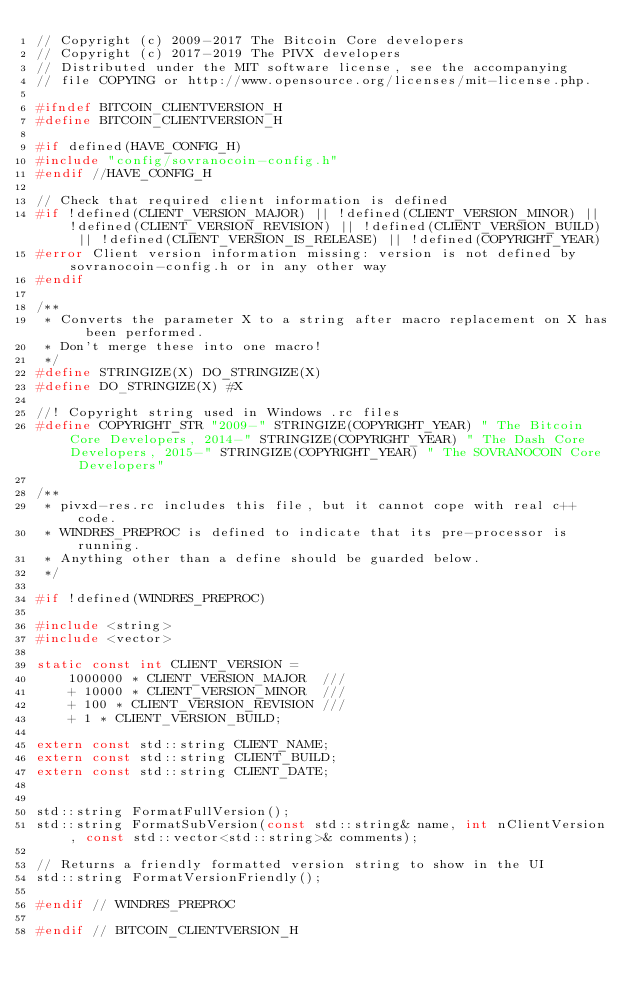<code> <loc_0><loc_0><loc_500><loc_500><_C_>// Copyright (c) 2009-2017 The Bitcoin Core developers
// Copyright (c) 2017-2019 The PIVX developers
// Distributed under the MIT software license, see the accompanying
// file COPYING or http://www.opensource.org/licenses/mit-license.php.

#ifndef BITCOIN_CLIENTVERSION_H
#define BITCOIN_CLIENTVERSION_H

#if defined(HAVE_CONFIG_H)
#include "config/sovranocoin-config.h"
#endif //HAVE_CONFIG_H

// Check that required client information is defined
#if !defined(CLIENT_VERSION_MAJOR) || !defined(CLIENT_VERSION_MINOR) || !defined(CLIENT_VERSION_REVISION) || !defined(CLIENT_VERSION_BUILD) || !defined(CLIENT_VERSION_IS_RELEASE) || !defined(COPYRIGHT_YEAR)
#error Client version information missing: version is not defined by sovranocoin-config.h or in any other way
#endif

/**
 * Converts the parameter X to a string after macro replacement on X has been performed.
 * Don't merge these into one macro!
 */
#define STRINGIZE(X) DO_STRINGIZE(X)
#define DO_STRINGIZE(X) #X

//! Copyright string used in Windows .rc files
#define COPYRIGHT_STR "2009-" STRINGIZE(COPYRIGHT_YEAR) " The Bitcoin Core Developers, 2014-" STRINGIZE(COPYRIGHT_YEAR) " The Dash Core Developers, 2015-" STRINGIZE(COPYRIGHT_YEAR) " The SOVRANOCOIN Core Developers"

/**
 * pivxd-res.rc includes this file, but it cannot cope with real c++ code.
 * WINDRES_PREPROC is defined to indicate that its pre-processor is running.
 * Anything other than a define should be guarded below.
 */

#if !defined(WINDRES_PREPROC)

#include <string>
#include <vector>

static const int CLIENT_VERSION =
    1000000 * CLIENT_VERSION_MAJOR  ///
    + 10000 * CLIENT_VERSION_MINOR  ///
    + 100 * CLIENT_VERSION_REVISION ///
    + 1 * CLIENT_VERSION_BUILD;

extern const std::string CLIENT_NAME;
extern const std::string CLIENT_BUILD;
extern const std::string CLIENT_DATE;


std::string FormatFullVersion();
std::string FormatSubVersion(const std::string& name, int nClientVersion, const std::vector<std::string>& comments);

// Returns a friendly formatted version string to show in the UI
std::string FormatVersionFriendly();

#endif // WINDRES_PREPROC

#endif // BITCOIN_CLIENTVERSION_H
</code> 